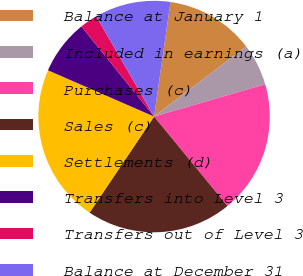Convert chart. <chart><loc_0><loc_0><loc_500><loc_500><pie_chart><fcel>Balance at January 1<fcel>Included in earnings (a)<fcel>Purchases (c)<fcel>Sales (c)<fcel>Settlements (d)<fcel>Transfers into Level 3<fcel>Transfers out of Level 3<fcel>Balance at December 31<nl><fcel>12.38%<fcel>5.86%<fcel>18.56%<fcel>20.35%<fcel>22.13%<fcel>7.65%<fcel>2.48%<fcel>10.59%<nl></chart> 